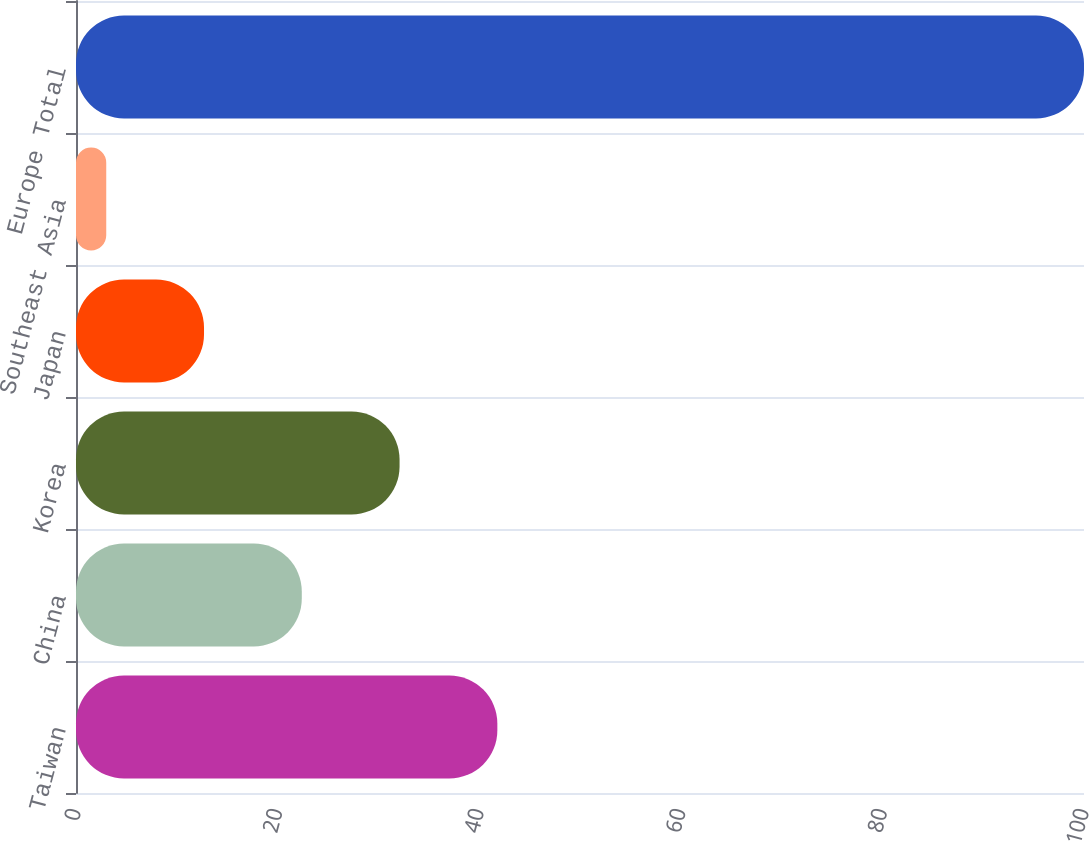<chart> <loc_0><loc_0><loc_500><loc_500><bar_chart><fcel>Taiwan<fcel>China<fcel>Korea<fcel>Japan<fcel>Southeast Asia<fcel>Europe Total<nl><fcel>41.8<fcel>22.4<fcel>32.1<fcel>12.7<fcel>3<fcel>100<nl></chart> 